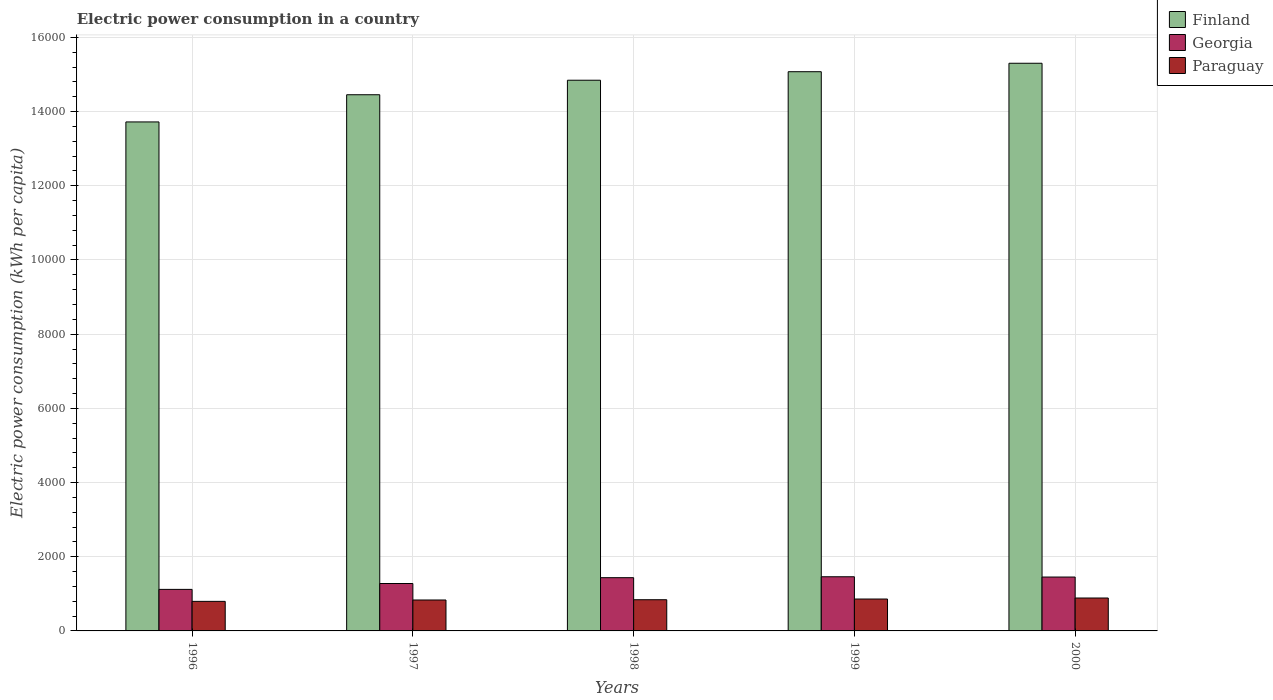How many different coloured bars are there?
Offer a very short reply. 3. How many groups of bars are there?
Provide a short and direct response. 5. Are the number of bars per tick equal to the number of legend labels?
Ensure brevity in your answer.  Yes. Are the number of bars on each tick of the X-axis equal?
Your response must be concise. Yes. How many bars are there on the 3rd tick from the left?
Provide a short and direct response. 3. How many bars are there on the 4th tick from the right?
Offer a terse response. 3. What is the label of the 4th group of bars from the left?
Keep it short and to the point. 1999. What is the electric power consumption in in Georgia in 1998?
Give a very brief answer. 1435.38. Across all years, what is the maximum electric power consumption in in Paraguay?
Offer a terse response. 887.47. Across all years, what is the minimum electric power consumption in in Georgia?
Keep it short and to the point. 1119.78. In which year was the electric power consumption in in Paraguay maximum?
Give a very brief answer. 2000. In which year was the electric power consumption in in Georgia minimum?
Provide a short and direct response. 1996. What is the total electric power consumption in in Georgia in the graph?
Offer a terse response. 6746.2. What is the difference between the electric power consumption in in Georgia in 1997 and that in 2000?
Your answer should be compact. -174.69. What is the difference between the electric power consumption in in Finland in 1998 and the electric power consumption in in Georgia in 1999?
Give a very brief answer. 1.34e+04. What is the average electric power consumption in in Finland per year?
Your response must be concise. 1.47e+04. In the year 1998, what is the difference between the electric power consumption in in Georgia and electric power consumption in in Paraguay?
Offer a very short reply. 594.41. What is the ratio of the electric power consumption in in Georgia in 1997 to that in 1998?
Offer a terse response. 0.89. Is the electric power consumption in in Georgia in 1996 less than that in 1997?
Provide a short and direct response. Yes. Is the difference between the electric power consumption in in Georgia in 1996 and 1999 greater than the difference between the electric power consumption in in Paraguay in 1996 and 1999?
Keep it short and to the point. No. What is the difference between the highest and the second highest electric power consumption in in Paraguay?
Give a very brief answer. 27.73. What is the difference between the highest and the lowest electric power consumption in in Paraguay?
Provide a succinct answer. 90.67. In how many years, is the electric power consumption in in Georgia greater than the average electric power consumption in in Georgia taken over all years?
Offer a terse response. 3. Is the sum of the electric power consumption in in Georgia in 1998 and 1999 greater than the maximum electric power consumption in in Paraguay across all years?
Your response must be concise. Yes. What does the 3rd bar from the left in 1996 represents?
Give a very brief answer. Paraguay. What does the 3rd bar from the right in 1998 represents?
Make the answer very short. Finland. How many bars are there?
Your answer should be compact. 15. What is the difference between two consecutive major ticks on the Y-axis?
Your answer should be compact. 2000. Are the values on the major ticks of Y-axis written in scientific E-notation?
Offer a terse response. No. Does the graph contain grids?
Make the answer very short. Yes. Where does the legend appear in the graph?
Your response must be concise. Top right. How many legend labels are there?
Provide a short and direct response. 3. What is the title of the graph?
Ensure brevity in your answer.  Electric power consumption in a country. What is the label or title of the X-axis?
Ensure brevity in your answer.  Years. What is the label or title of the Y-axis?
Make the answer very short. Electric power consumption (kWh per capita). What is the Electric power consumption (kWh per capita) in Finland in 1996?
Ensure brevity in your answer.  1.37e+04. What is the Electric power consumption (kWh per capita) in Georgia in 1996?
Your answer should be compact. 1119.78. What is the Electric power consumption (kWh per capita) in Paraguay in 1996?
Provide a succinct answer. 796.81. What is the Electric power consumption (kWh per capita) of Finland in 1997?
Offer a very short reply. 1.45e+04. What is the Electric power consumption (kWh per capita) in Georgia in 1997?
Keep it short and to the point. 1278.14. What is the Electric power consumption (kWh per capita) in Paraguay in 1997?
Offer a very short reply. 833.88. What is the Electric power consumption (kWh per capita) in Finland in 1998?
Make the answer very short. 1.48e+04. What is the Electric power consumption (kWh per capita) in Georgia in 1998?
Keep it short and to the point. 1435.38. What is the Electric power consumption (kWh per capita) in Paraguay in 1998?
Your answer should be very brief. 840.98. What is the Electric power consumption (kWh per capita) in Finland in 1999?
Your response must be concise. 1.51e+04. What is the Electric power consumption (kWh per capita) in Georgia in 1999?
Provide a short and direct response. 1460.08. What is the Electric power consumption (kWh per capita) of Paraguay in 1999?
Give a very brief answer. 859.74. What is the Electric power consumption (kWh per capita) in Finland in 2000?
Offer a terse response. 1.53e+04. What is the Electric power consumption (kWh per capita) of Georgia in 2000?
Ensure brevity in your answer.  1452.82. What is the Electric power consumption (kWh per capita) in Paraguay in 2000?
Provide a succinct answer. 887.47. Across all years, what is the maximum Electric power consumption (kWh per capita) of Finland?
Your answer should be very brief. 1.53e+04. Across all years, what is the maximum Electric power consumption (kWh per capita) in Georgia?
Offer a very short reply. 1460.08. Across all years, what is the maximum Electric power consumption (kWh per capita) in Paraguay?
Keep it short and to the point. 887.47. Across all years, what is the minimum Electric power consumption (kWh per capita) of Finland?
Give a very brief answer. 1.37e+04. Across all years, what is the minimum Electric power consumption (kWh per capita) in Georgia?
Ensure brevity in your answer.  1119.78. Across all years, what is the minimum Electric power consumption (kWh per capita) of Paraguay?
Provide a succinct answer. 796.81. What is the total Electric power consumption (kWh per capita) of Finland in the graph?
Provide a succinct answer. 7.34e+04. What is the total Electric power consumption (kWh per capita) in Georgia in the graph?
Provide a succinct answer. 6746.2. What is the total Electric power consumption (kWh per capita) of Paraguay in the graph?
Your response must be concise. 4218.87. What is the difference between the Electric power consumption (kWh per capita) in Finland in 1996 and that in 1997?
Provide a succinct answer. -733.01. What is the difference between the Electric power consumption (kWh per capita) in Georgia in 1996 and that in 1997?
Give a very brief answer. -158.36. What is the difference between the Electric power consumption (kWh per capita) in Paraguay in 1996 and that in 1997?
Provide a short and direct response. -37.07. What is the difference between the Electric power consumption (kWh per capita) in Finland in 1996 and that in 1998?
Provide a short and direct response. -1124.5. What is the difference between the Electric power consumption (kWh per capita) in Georgia in 1996 and that in 1998?
Ensure brevity in your answer.  -315.61. What is the difference between the Electric power consumption (kWh per capita) of Paraguay in 1996 and that in 1998?
Make the answer very short. -44.17. What is the difference between the Electric power consumption (kWh per capita) of Finland in 1996 and that in 1999?
Make the answer very short. -1353.94. What is the difference between the Electric power consumption (kWh per capita) in Georgia in 1996 and that in 1999?
Give a very brief answer. -340.3. What is the difference between the Electric power consumption (kWh per capita) of Paraguay in 1996 and that in 1999?
Ensure brevity in your answer.  -62.93. What is the difference between the Electric power consumption (kWh per capita) in Finland in 1996 and that in 2000?
Offer a very short reply. -1581.94. What is the difference between the Electric power consumption (kWh per capita) in Georgia in 1996 and that in 2000?
Your answer should be very brief. -333.04. What is the difference between the Electric power consumption (kWh per capita) of Paraguay in 1996 and that in 2000?
Your answer should be very brief. -90.67. What is the difference between the Electric power consumption (kWh per capita) of Finland in 1997 and that in 1998?
Provide a short and direct response. -391.48. What is the difference between the Electric power consumption (kWh per capita) of Georgia in 1997 and that in 1998?
Ensure brevity in your answer.  -157.25. What is the difference between the Electric power consumption (kWh per capita) in Paraguay in 1997 and that in 1998?
Provide a short and direct response. -7.1. What is the difference between the Electric power consumption (kWh per capita) in Finland in 1997 and that in 1999?
Make the answer very short. -620.93. What is the difference between the Electric power consumption (kWh per capita) of Georgia in 1997 and that in 1999?
Your answer should be compact. -181.94. What is the difference between the Electric power consumption (kWh per capita) of Paraguay in 1997 and that in 1999?
Your answer should be very brief. -25.86. What is the difference between the Electric power consumption (kWh per capita) in Finland in 1997 and that in 2000?
Provide a succinct answer. -848.93. What is the difference between the Electric power consumption (kWh per capita) of Georgia in 1997 and that in 2000?
Give a very brief answer. -174.69. What is the difference between the Electric power consumption (kWh per capita) of Paraguay in 1997 and that in 2000?
Your answer should be very brief. -53.59. What is the difference between the Electric power consumption (kWh per capita) of Finland in 1998 and that in 1999?
Give a very brief answer. -229.45. What is the difference between the Electric power consumption (kWh per capita) in Georgia in 1998 and that in 1999?
Offer a terse response. -24.69. What is the difference between the Electric power consumption (kWh per capita) in Paraguay in 1998 and that in 1999?
Keep it short and to the point. -18.76. What is the difference between the Electric power consumption (kWh per capita) in Finland in 1998 and that in 2000?
Offer a very short reply. -457.44. What is the difference between the Electric power consumption (kWh per capita) in Georgia in 1998 and that in 2000?
Offer a terse response. -17.44. What is the difference between the Electric power consumption (kWh per capita) of Paraguay in 1998 and that in 2000?
Provide a short and direct response. -46.49. What is the difference between the Electric power consumption (kWh per capita) in Finland in 1999 and that in 2000?
Make the answer very short. -228. What is the difference between the Electric power consumption (kWh per capita) in Georgia in 1999 and that in 2000?
Your answer should be very brief. 7.26. What is the difference between the Electric power consumption (kWh per capita) of Paraguay in 1999 and that in 2000?
Offer a very short reply. -27.73. What is the difference between the Electric power consumption (kWh per capita) of Finland in 1996 and the Electric power consumption (kWh per capita) of Georgia in 1997?
Offer a very short reply. 1.24e+04. What is the difference between the Electric power consumption (kWh per capita) in Finland in 1996 and the Electric power consumption (kWh per capita) in Paraguay in 1997?
Your answer should be compact. 1.29e+04. What is the difference between the Electric power consumption (kWh per capita) in Georgia in 1996 and the Electric power consumption (kWh per capita) in Paraguay in 1997?
Offer a terse response. 285.9. What is the difference between the Electric power consumption (kWh per capita) in Finland in 1996 and the Electric power consumption (kWh per capita) in Georgia in 1998?
Keep it short and to the point. 1.23e+04. What is the difference between the Electric power consumption (kWh per capita) of Finland in 1996 and the Electric power consumption (kWh per capita) of Paraguay in 1998?
Your answer should be compact. 1.29e+04. What is the difference between the Electric power consumption (kWh per capita) of Georgia in 1996 and the Electric power consumption (kWh per capita) of Paraguay in 1998?
Ensure brevity in your answer.  278.8. What is the difference between the Electric power consumption (kWh per capita) in Finland in 1996 and the Electric power consumption (kWh per capita) in Georgia in 1999?
Your answer should be compact. 1.23e+04. What is the difference between the Electric power consumption (kWh per capita) of Finland in 1996 and the Electric power consumption (kWh per capita) of Paraguay in 1999?
Your answer should be very brief. 1.29e+04. What is the difference between the Electric power consumption (kWh per capita) in Georgia in 1996 and the Electric power consumption (kWh per capita) in Paraguay in 1999?
Your response must be concise. 260.04. What is the difference between the Electric power consumption (kWh per capita) in Finland in 1996 and the Electric power consumption (kWh per capita) in Georgia in 2000?
Ensure brevity in your answer.  1.23e+04. What is the difference between the Electric power consumption (kWh per capita) of Finland in 1996 and the Electric power consumption (kWh per capita) of Paraguay in 2000?
Your answer should be very brief. 1.28e+04. What is the difference between the Electric power consumption (kWh per capita) of Georgia in 1996 and the Electric power consumption (kWh per capita) of Paraguay in 2000?
Ensure brevity in your answer.  232.3. What is the difference between the Electric power consumption (kWh per capita) in Finland in 1997 and the Electric power consumption (kWh per capita) in Georgia in 1998?
Your answer should be very brief. 1.30e+04. What is the difference between the Electric power consumption (kWh per capita) of Finland in 1997 and the Electric power consumption (kWh per capita) of Paraguay in 1998?
Offer a terse response. 1.36e+04. What is the difference between the Electric power consumption (kWh per capita) in Georgia in 1997 and the Electric power consumption (kWh per capita) in Paraguay in 1998?
Offer a terse response. 437.16. What is the difference between the Electric power consumption (kWh per capita) in Finland in 1997 and the Electric power consumption (kWh per capita) in Georgia in 1999?
Give a very brief answer. 1.30e+04. What is the difference between the Electric power consumption (kWh per capita) of Finland in 1997 and the Electric power consumption (kWh per capita) of Paraguay in 1999?
Provide a short and direct response. 1.36e+04. What is the difference between the Electric power consumption (kWh per capita) of Georgia in 1997 and the Electric power consumption (kWh per capita) of Paraguay in 1999?
Your answer should be very brief. 418.4. What is the difference between the Electric power consumption (kWh per capita) of Finland in 1997 and the Electric power consumption (kWh per capita) of Georgia in 2000?
Your answer should be compact. 1.30e+04. What is the difference between the Electric power consumption (kWh per capita) of Finland in 1997 and the Electric power consumption (kWh per capita) of Paraguay in 2000?
Make the answer very short. 1.36e+04. What is the difference between the Electric power consumption (kWh per capita) in Georgia in 1997 and the Electric power consumption (kWh per capita) in Paraguay in 2000?
Provide a short and direct response. 390.66. What is the difference between the Electric power consumption (kWh per capita) in Finland in 1998 and the Electric power consumption (kWh per capita) in Georgia in 1999?
Keep it short and to the point. 1.34e+04. What is the difference between the Electric power consumption (kWh per capita) of Finland in 1998 and the Electric power consumption (kWh per capita) of Paraguay in 1999?
Provide a succinct answer. 1.40e+04. What is the difference between the Electric power consumption (kWh per capita) in Georgia in 1998 and the Electric power consumption (kWh per capita) in Paraguay in 1999?
Your response must be concise. 575.65. What is the difference between the Electric power consumption (kWh per capita) in Finland in 1998 and the Electric power consumption (kWh per capita) in Georgia in 2000?
Ensure brevity in your answer.  1.34e+04. What is the difference between the Electric power consumption (kWh per capita) of Finland in 1998 and the Electric power consumption (kWh per capita) of Paraguay in 2000?
Keep it short and to the point. 1.40e+04. What is the difference between the Electric power consumption (kWh per capita) in Georgia in 1998 and the Electric power consumption (kWh per capita) in Paraguay in 2000?
Provide a short and direct response. 547.91. What is the difference between the Electric power consumption (kWh per capita) of Finland in 1999 and the Electric power consumption (kWh per capita) of Georgia in 2000?
Your answer should be compact. 1.36e+04. What is the difference between the Electric power consumption (kWh per capita) in Finland in 1999 and the Electric power consumption (kWh per capita) in Paraguay in 2000?
Your answer should be very brief. 1.42e+04. What is the difference between the Electric power consumption (kWh per capita) of Georgia in 1999 and the Electric power consumption (kWh per capita) of Paraguay in 2000?
Your response must be concise. 572.61. What is the average Electric power consumption (kWh per capita) in Finland per year?
Make the answer very short. 1.47e+04. What is the average Electric power consumption (kWh per capita) in Georgia per year?
Offer a terse response. 1349.24. What is the average Electric power consumption (kWh per capita) of Paraguay per year?
Provide a succinct answer. 843.77. In the year 1996, what is the difference between the Electric power consumption (kWh per capita) of Finland and Electric power consumption (kWh per capita) of Georgia?
Your response must be concise. 1.26e+04. In the year 1996, what is the difference between the Electric power consumption (kWh per capita) in Finland and Electric power consumption (kWh per capita) in Paraguay?
Keep it short and to the point. 1.29e+04. In the year 1996, what is the difference between the Electric power consumption (kWh per capita) in Georgia and Electric power consumption (kWh per capita) in Paraguay?
Provide a short and direct response. 322.97. In the year 1997, what is the difference between the Electric power consumption (kWh per capita) of Finland and Electric power consumption (kWh per capita) of Georgia?
Offer a very short reply. 1.32e+04. In the year 1997, what is the difference between the Electric power consumption (kWh per capita) in Finland and Electric power consumption (kWh per capita) in Paraguay?
Your answer should be very brief. 1.36e+04. In the year 1997, what is the difference between the Electric power consumption (kWh per capita) in Georgia and Electric power consumption (kWh per capita) in Paraguay?
Offer a terse response. 444.26. In the year 1998, what is the difference between the Electric power consumption (kWh per capita) of Finland and Electric power consumption (kWh per capita) of Georgia?
Provide a short and direct response. 1.34e+04. In the year 1998, what is the difference between the Electric power consumption (kWh per capita) in Finland and Electric power consumption (kWh per capita) in Paraguay?
Give a very brief answer. 1.40e+04. In the year 1998, what is the difference between the Electric power consumption (kWh per capita) of Georgia and Electric power consumption (kWh per capita) of Paraguay?
Offer a terse response. 594.41. In the year 1999, what is the difference between the Electric power consumption (kWh per capita) in Finland and Electric power consumption (kWh per capita) in Georgia?
Your answer should be very brief. 1.36e+04. In the year 1999, what is the difference between the Electric power consumption (kWh per capita) of Finland and Electric power consumption (kWh per capita) of Paraguay?
Provide a succinct answer. 1.42e+04. In the year 1999, what is the difference between the Electric power consumption (kWh per capita) of Georgia and Electric power consumption (kWh per capita) of Paraguay?
Make the answer very short. 600.34. In the year 2000, what is the difference between the Electric power consumption (kWh per capita) in Finland and Electric power consumption (kWh per capita) in Georgia?
Provide a short and direct response. 1.39e+04. In the year 2000, what is the difference between the Electric power consumption (kWh per capita) of Finland and Electric power consumption (kWh per capita) of Paraguay?
Make the answer very short. 1.44e+04. In the year 2000, what is the difference between the Electric power consumption (kWh per capita) of Georgia and Electric power consumption (kWh per capita) of Paraguay?
Ensure brevity in your answer.  565.35. What is the ratio of the Electric power consumption (kWh per capita) in Finland in 1996 to that in 1997?
Offer a very short reply. 0.95. What is the ratio of the Electric power consumption (kWh per capita) of Georgia in 1996 to that in 1997?
Offer a very short reply. 0.88. What is the ratio of the Electric power consumption (kWh per capita) of Paraguay in 1996 to that in 1997?
Provide a short and direct response. 0.96. What is the ratio of the Electric power consumption (kWh per capita) of Finland in 1996 to that in 1998?
Give a very brief answer. 0.92. What is the ratio of the Electric power consumption (kWh per capita) of Georgia in 1996 to that in 1998?
Give a very brief answer. 0.78. What is the ratio of the Electric power consumption (kWh per capita) of Paraguay in 1996 to that in 1998?
Offer a very short reply. 0.95. What is the ratio of the Electric power consumption (kWh per capita) in Finland in 1996 to that in 1999?
Your answer should be compact. 0.91. What is the ratio of the Electric power consumption (kWh per capita) of Georgia in 1996 to that in 1999?
Your answer should be compact. 0.77. What is the ratio of the Electric power consumption (kWh per capita) of Paraguay in 1996 to that in 1999?
Give a very brief answer. 0.93. What is the ratio of the Electric power consumption (kWh per capita) of Finland in 1996 to that in 2000?
Offer a very short reply. 0.9. What is the ratio of the Electric power consumption (kWh per capita) in Georgia in 1996 to that in 2000?
Provide a short and direct response. 0.77. What is the ratio of the Electric power consumption (kWh per capita) of Paraguay in 1996 to that in 2000?
Make the answer very short. 0.9. What is the ratio of the Electric power consumption (kWh per capita) of Finland in 1997 to that in 1998?
Offer a terse response. 0.97. What is the ratio of the Electric power consumption (kWh per capita) of Georgia in 1997 to that in 1998?
Ensure brevity in your answer.  0.89. What is the ratio of the Electric power consumption (kWh per capita) of Paraguay in 1997 to that in 1998?
Ensure brevity in your answer.  0.99. What is the ratio of the Electric power consumption (kWh per capita) of Finland in 1997 to that in 1999?
Your answer should be very brief. 0.96. What is the ratio of the Electric power consumption (kWh per capita) in Georgia in 1997 to that in 1999?
Your answer should be compact. 0.88. What is the ratio of the Electric power consumption (kWh per capita) in Paraguay in 1997 to that in 1999?
Give a very brief answer. 0.97. What is the ratio of the Electric power consumption (kWh per capita) in Finland in 1997 to that in 2000?
Ensure brevity in your answer.  0.94. What is the ratio of the Electric power consumption (kWh per capita) of Georgia in 1997 to that in 2000?
Offer a terse response. 0.88. What is the ratio of the Electric power consumption (kWh per capita) in Paraguay in 1997 to that in 2000?
Your answer should be very brief. 0.94. What is the ratio of the Electric power consumption (kWh per capita) in Finland in 1998 to that in 1999?
Keep it short and to the point. 0.98. What is the ratio of the Electric power consumption (kWh per capita) in Georgia in 1998 to that in 1999?
Keep it short and to the point. 0.98. What is the ratio of the Electric power consumption (kWh per capita) in Paraguay in 1998 to that in 1999?
Your answer should be very brief. 0.98. What is the ratio of the Electric power consumption (kWh per capita) in Finland in 1998 to that in 2000?
Provide a short and direct response. 0.97. What is the ratio of the Electric power consumption (kWh per capita) in Paraguay in 1998 to that in 2000?
Offer a terse response. 0.95. What is the ratio of the Electric power consumption (kWh per capita) of Finland in 1999 to that in 2000?
Keep it short and to the point. 0.99. What is the ratio of the Electric power consumption (kWh per capita) of Paraguay in 1999 to that in 2000?
Your answer should be compact. 0.97. What is the difference between the highest and the second highest Electric power consumption (kWh per capita) of Finland?
Provide a short and direct response. 228. What is the difference between the highest and the second highest Electric power consumption (kWh per capita) in Georgia?
Provide a short and direct response. 7.26. What is the difference between the highest and the second highest Electric power consumption (kWh per capita) of Paraguay?
Give a very brief answer. 27.73. What is the difference between the highest and the lowest Electric power consumption (kWh per capita) of Finland?
Offer a very short reply. 1581.94. What is the difference between the highest and the lowest Electric power consumption (kWh per capita) in Georgia?
Offer a terse response. 340.3. What is the difference between the highest and the lowest Electric power consumption (kWh per capita) in Paraguay?
Provide a succinct answer. 90.67. 